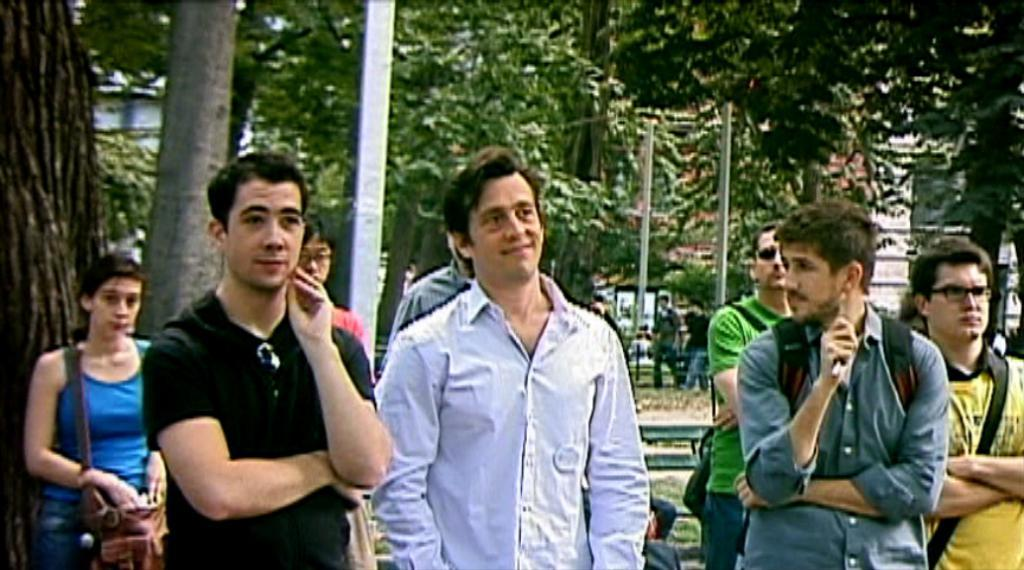What are the people in the image doing? The people in the image are standing on the ground. What can be seen in the background of the image? Trees and poles are visible in the background of the image. Can you describe any other elements in the background of the image? There are other unspecified elements in the background of the image. Are there any dinosaurs visible in the image? No, there are no dinosaurs present in the image. Can you tell me what type of coast is visible in the image? There is no coast visible in the image; it features people standing on the ground with trees and poles in the background. 